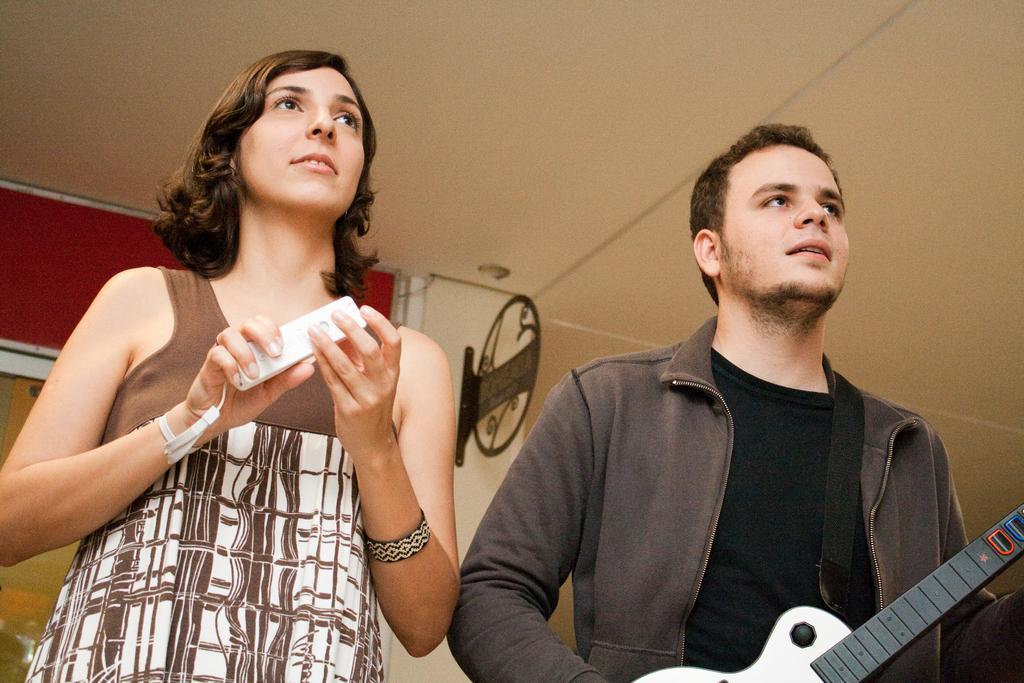Please provide a concise description of this image. In this picture we can see man wore jacket holding guitar in his hand and beside to him woman smiling and holding phone in her hand and in background we can see wall. 